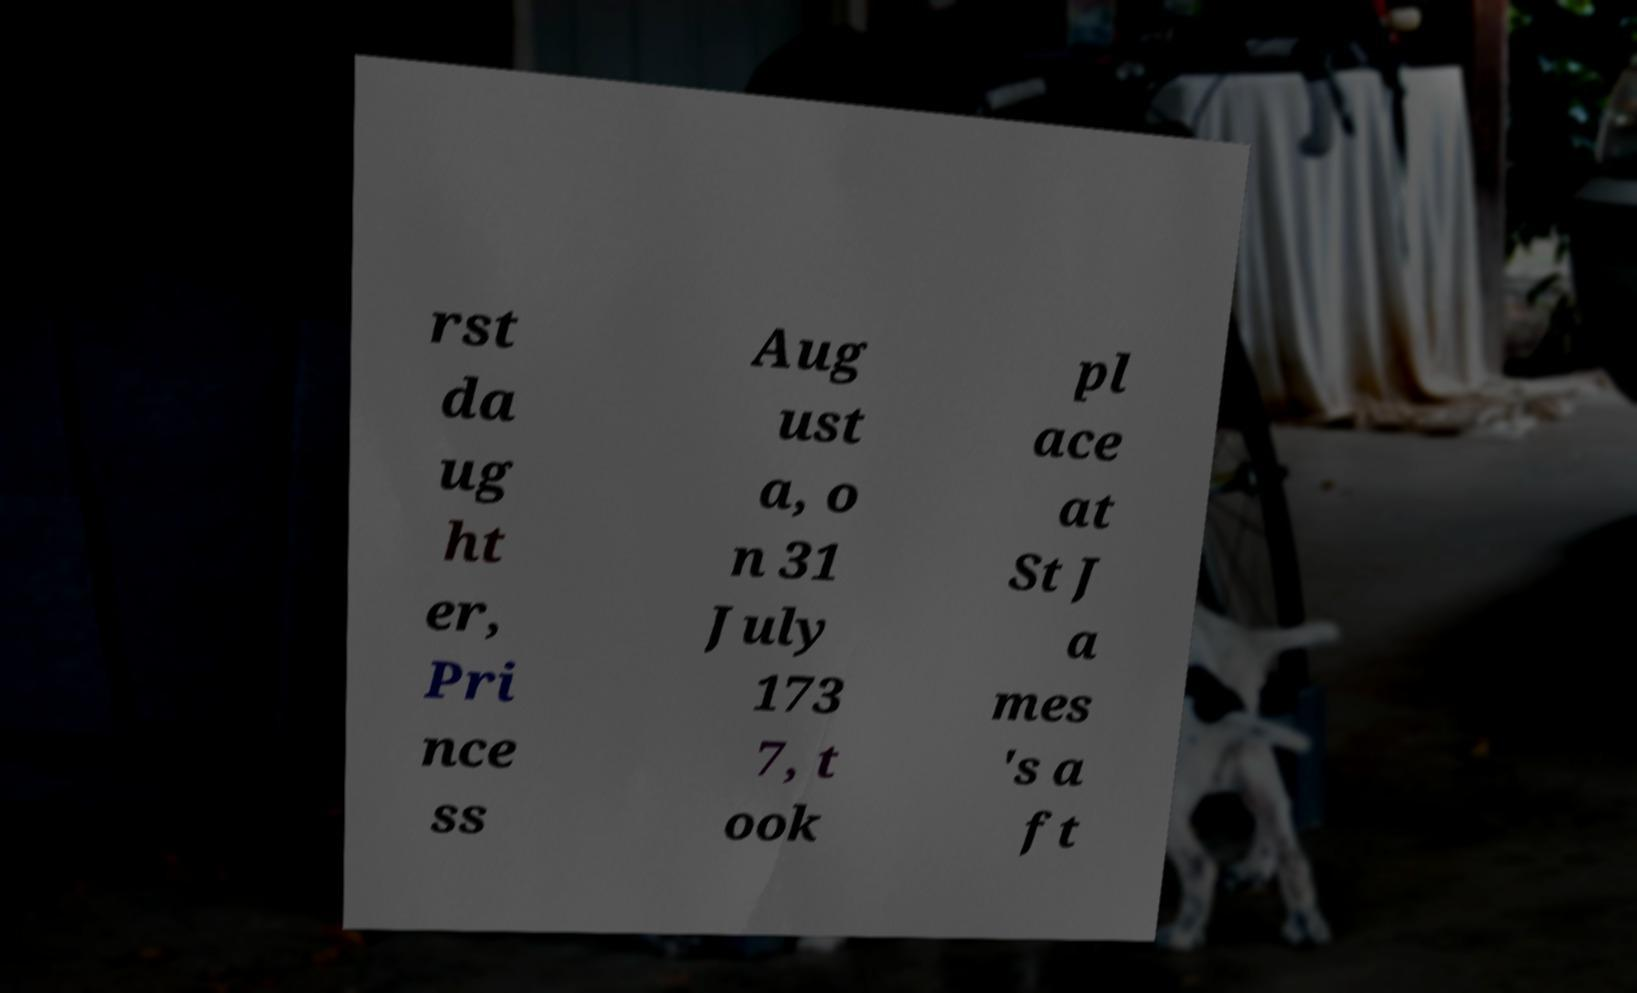What messages or text are displayed in this image? I need them in a readable, typed format. rst da ug ht er, Pri nce ss Aug ust a, o n 31 July 173 7, t ook pl ace at St J a mes 's a ft 